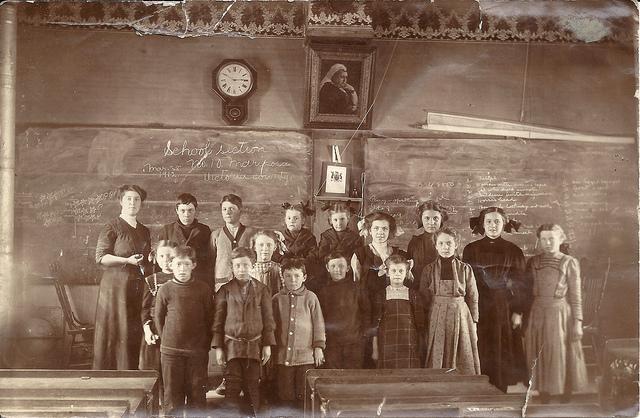What type of picture do you call this?
Short answer required. Old. Are these people holding a giant license plate?
Be succinct. No. Is there a clock in this photo?
Keep it brief. Yes. What type of board is behind the people?
Be succinct. Chalkboard. What are the people holding?
Write a very short answer. Nothing. Is this a vintage picture?
Short answer required. Yes. 